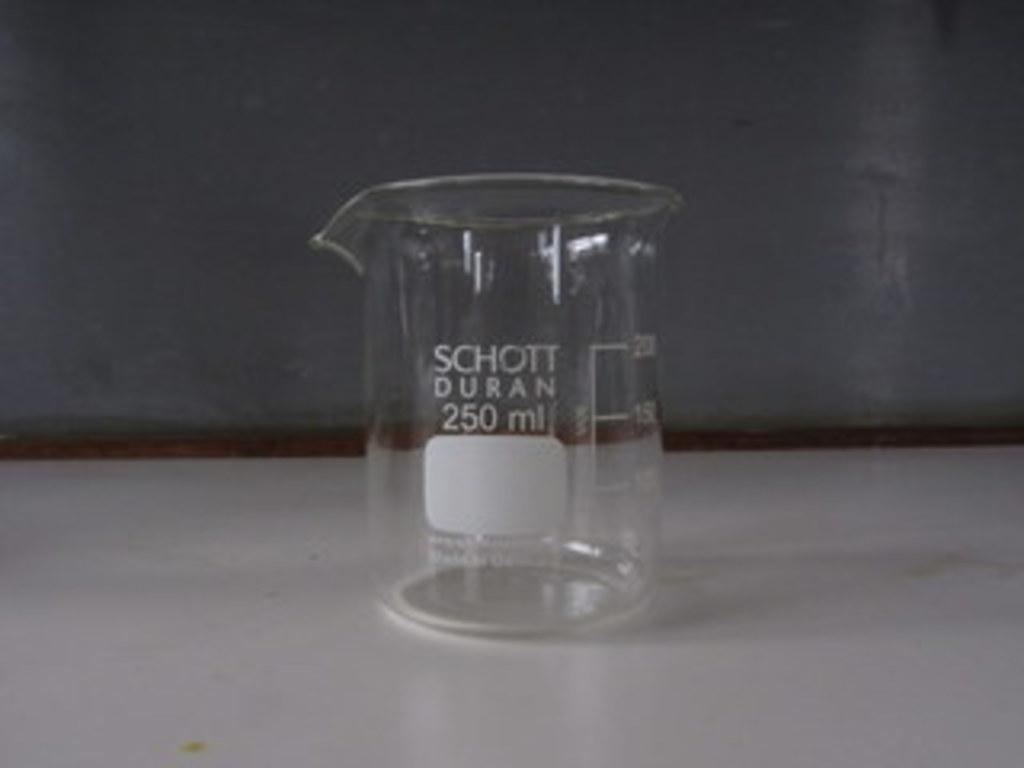<image>
Summarize the visual content of the image. On a table sits a 250 mL measuring cup from SCHOTT DURAN. 